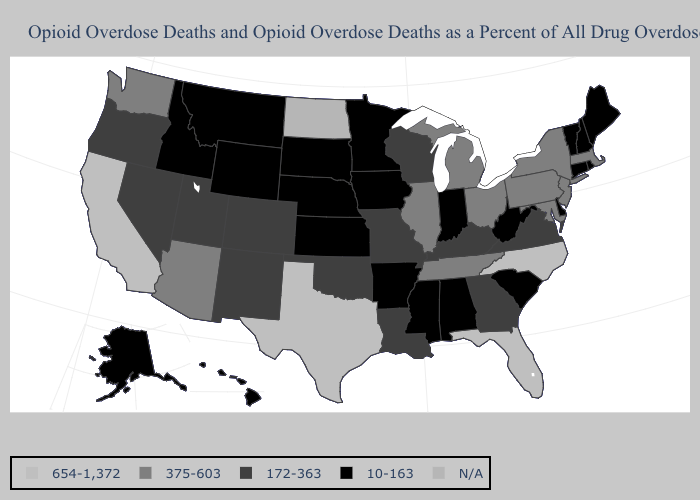What is the value of Delaware?
Keep it brief. 10-163. Does Delaware have the lowest value in the South?
Quick response, please. Yes. Is the legend a continuous bar?
Concise answer only. No. Among the states that border Alabama , does Tennessee have the lowest value?
Give a very brief answer. No. What is the highest value in the USA?
Write a very short answer. 654-1,372. What is the value of Alabama?
Quick response, please. 10-163. Which states have the highest value in the USA?
Short answer required. California, Florida, North Carolina, Texas. What is the value of Texas?
Short answer required. 654-1,372. Name the states that have a value in the range 172-363?
Give a very brief answer. Colorado, Georgia, Kentucky, Louisiana, Missouri, Nevada, New Mexico, Oklahoma, Oregon, Utah, Virginia, Wisconsin. Name the states that have a value in the range 172-363?
Write a very short answer. Colorado, Georgia, Kentucky, Louisiana, Missouri, Nevada, New Mexico, Oklahoma, Oregon, Utah, Virginia, Wisconsin. Among the states that border Arkansas , which have the highest value?
Quick response, please. Texas. Does Arizona have the lowest value in the USA?
Answer briefly. No. Name the states that have a value in the range 654-1,372?
Write a very short answer. California, Florida, North Carolina, Texas. What is the value of Connecticut?
Keep it brief. 10-163. 